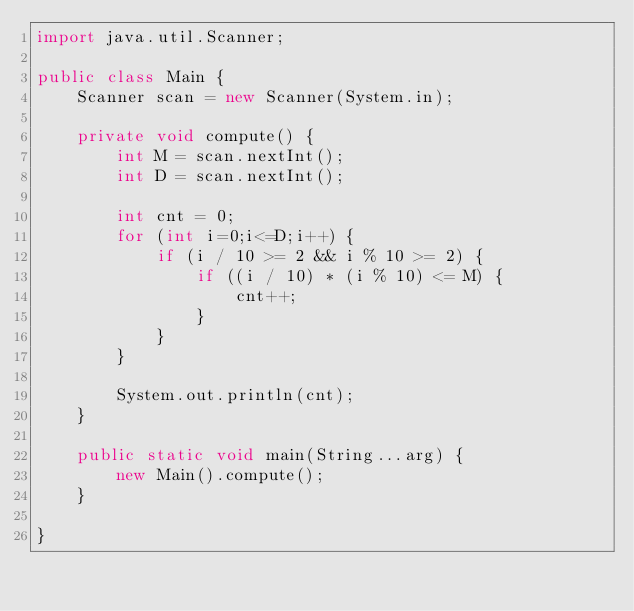<code> <loc_0><loc_0><loc_500><loc_500><_Java_>import java.util.Scanner;

public class Main {
	Scanner scan = new Scanner(System.in);
	
	private void compute() {
		int M = scan.nextInt();
		int D = scan.nextInt();
		
		int cnt = 0;
		for (int i=0;i<=D;i++) {
			if (i / 10 >= 2 && i % 10 >= 2) {
				if ((i / 10) * (i % 10) <= M) {
					cnt++;
				}
			}
		}
		
		System.out.println(cnt);
	}
	
	public static void main(String...arg) {
		new Main().compute();
	}

}
</code> 